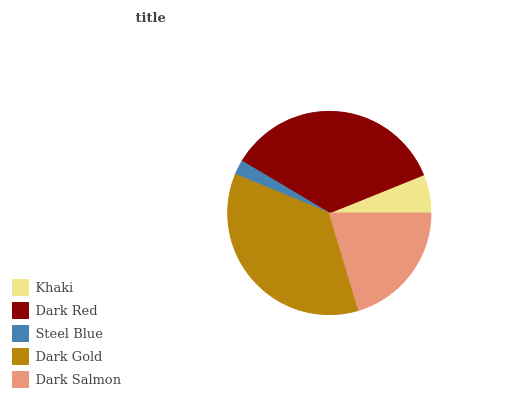Is Steel Blue the minimum?
Answer yes or no. Yes. Is Dark Gold the maximum?
Answer yes or no. Yes. Is Dark Red the minimum?
Answer yes or no. No. Is Dark Red the maximum?
Answer yes or no. No. Is Dark Red greater than Khaki?
Answer yes or no. Yes. Is Khaki less than Dark Red?
Answer yes or no. Yes. Is Khaki greater than Dark Red?
Answer yes or no. No. Is Dark Red less than Khaki?
Answer yes or no. No. Is Dark Salmon the high median?
Answer yes or no. Yes. Is Dark Salmon the low median?
Answer yes or no. Yes. Is Dark Red the high median?
Answer yes or no. No. Is Dark Gold the low median?
Answer yes or no. No. 